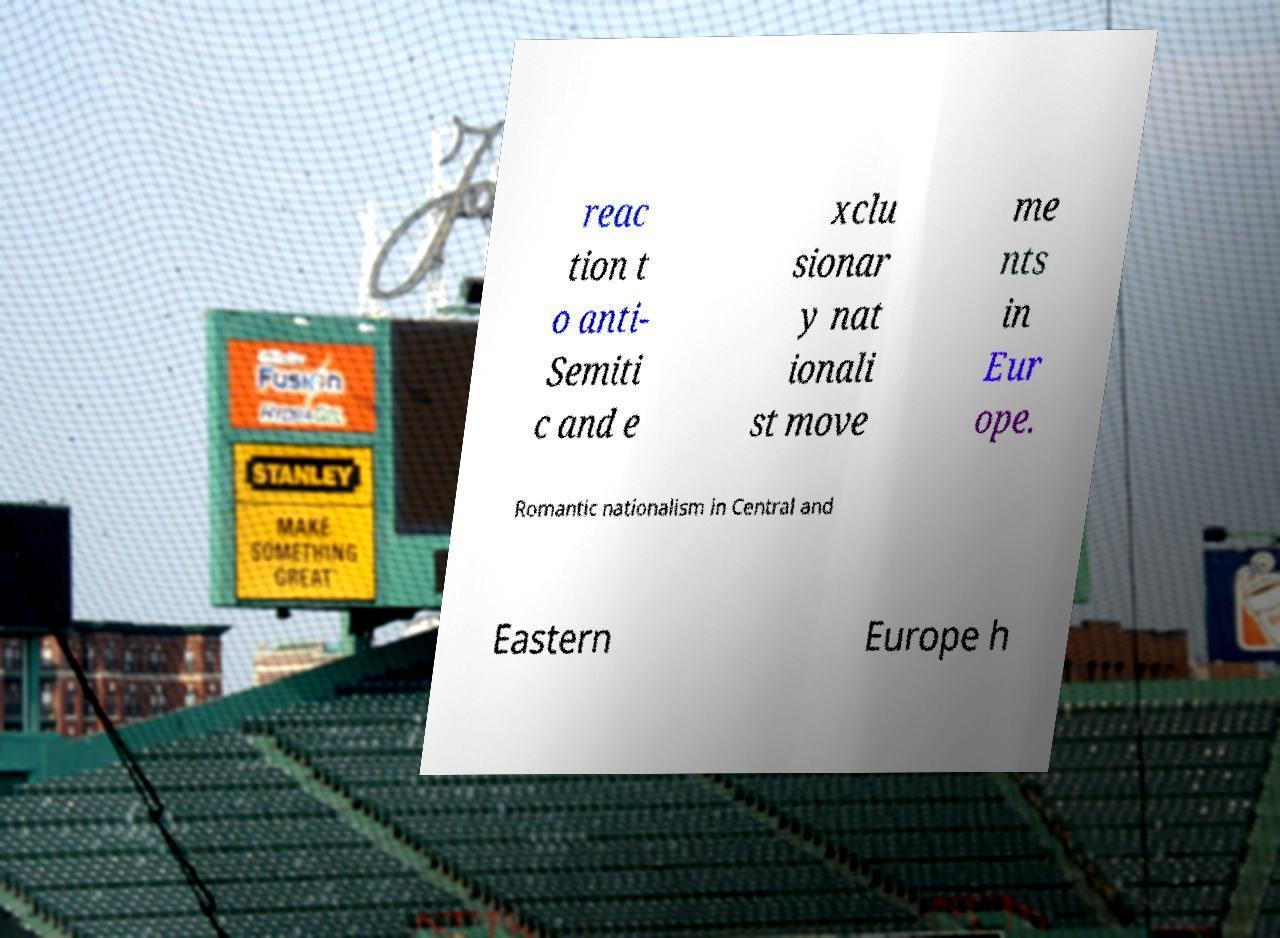I need the written content from this picture converted into text. Can you do that? reac tion t o anti- Semiti c and e xclu sionar y nat ionali st move me nts in Eur ope. Romantic nationalism in Central and Eastern Europe h 